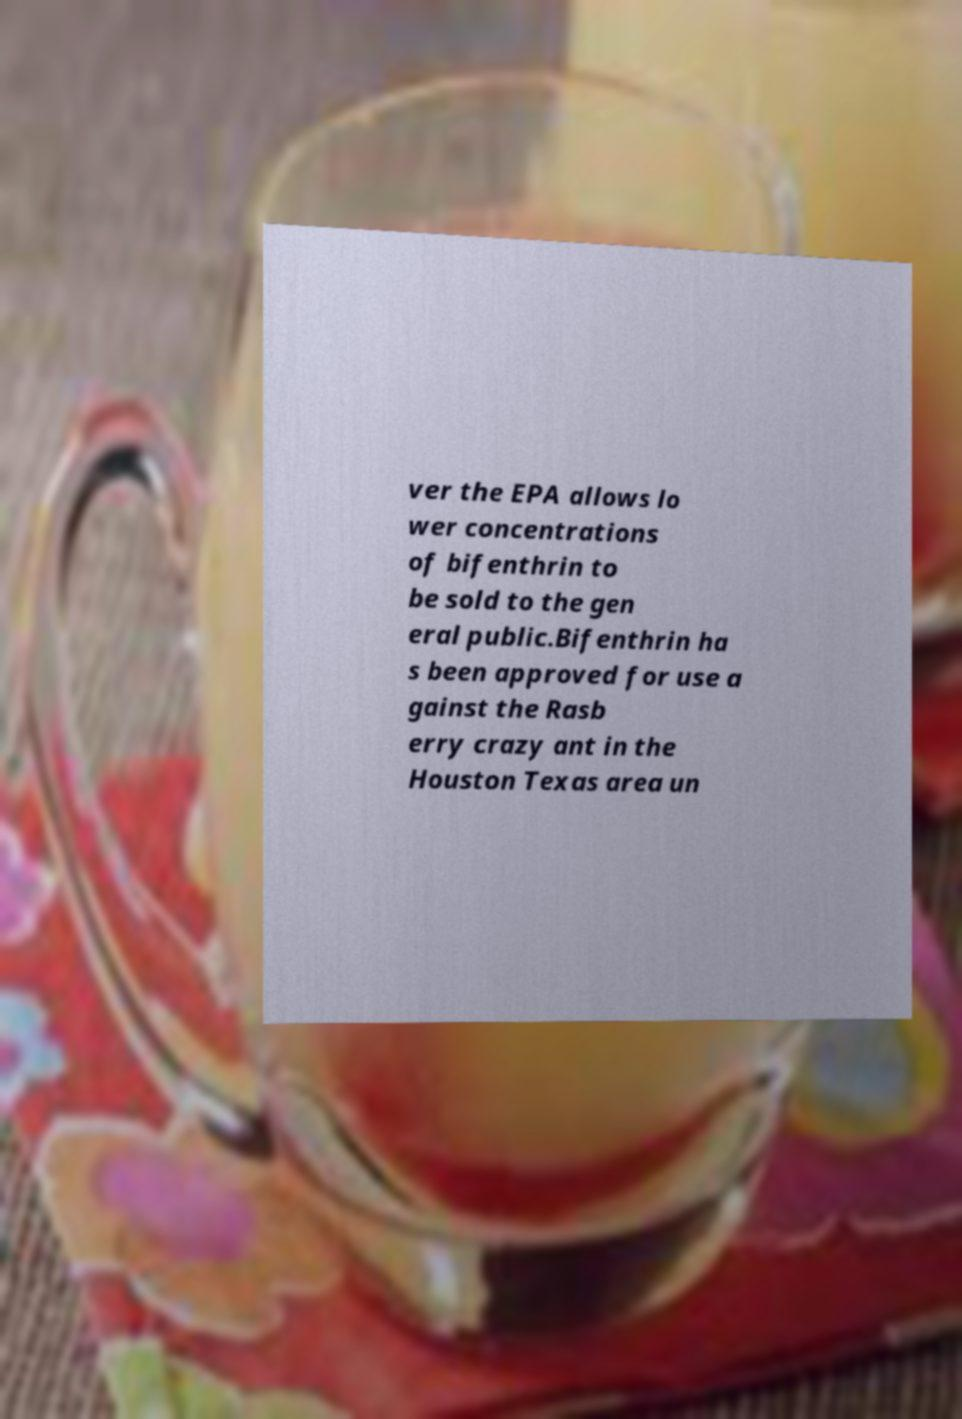Could you assist in decoding the text presented in this image and type it out clearly? ver the EPA allows lo wer concentrations of bifenthrin to be sold to the gen eral public.Bifenthrin ha s been approved for use a gainst the Rasb erry crazy ant in the Houston Texas area un 